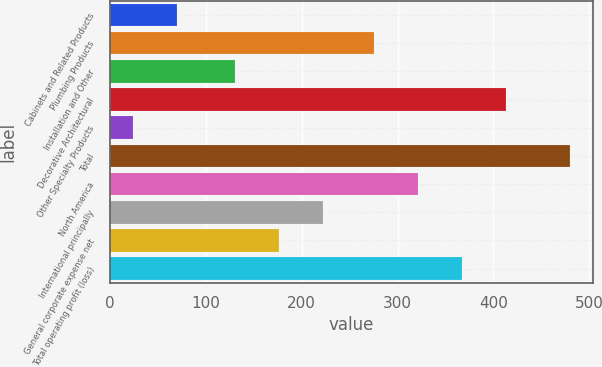Convert chart. <chart><loc_0><loc_0><loc_500><loc_500><bar_chart><fcel>Cabinets and Related Products<fcel>Plumbing Products<fcel>Installation and Other<fcel>Decorative Architectural<fcel>Other Specialty Products<fcel>Total<fcel>North America<fcel>International principally<fcel>General corporate expense net<fcel>Total operating profit (loss)<nl><fcel>69.6<fcel>276<fcel>131<fcel>412.8<fcel>24<fcel>480<fcel>321.6<fcel>222.2<fcel>176.6<fcel>367.2<nl></chart> 